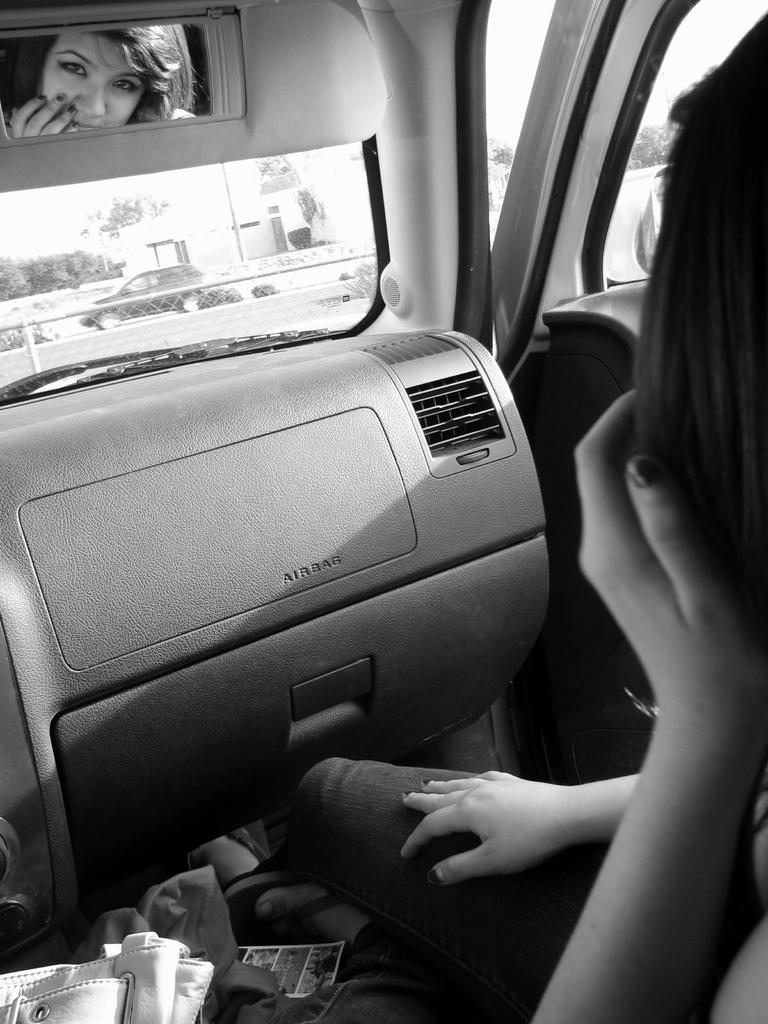What is the setting of the image? The image shows the interior of a car. What object is present in the car that can be used for self-reflection? There is a mirror in the car. Whose face can be seen in the mirror? A woman's face is visible in the mirror. What type of form can be seen popping out of the car's dashboard in the image? There is no form popping out of the car's dashboard in the image. Can you describe the popcorn machine located in the back seat of the car? There is no popcorn machine present in the image. 